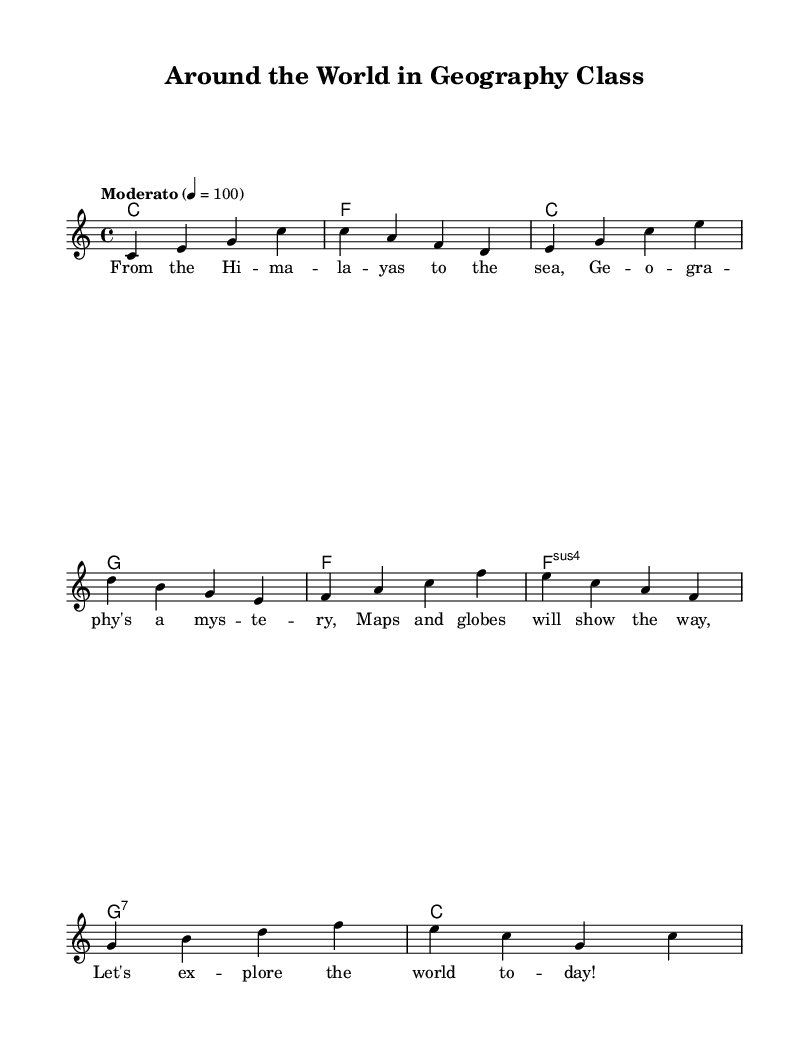What is the time signature of this music? The time signature is indicated at the beginning of the score and is shown as 4/4, meaning there are four beats in each measure, and the quarter note gets one beat.
Answer: 4/4 What key is this piece written in? The key signature is shown at the beginning and indicates C major, which has no sharps or flats.
Answer: C major What is the tempo marking of this piece? The tempo marking appears above the staff and indicates "Moderato" at a speed of 100 beats per minute, suggesting a moderate pace.
Answer: Moderato How many measures are in the music? By counting the measures in the melody line, we see there are 8 measures total in this piece, as each line is separated clearly in the notation.
Answer: 8 What is the first line of lyrics in the song? The first line of lyrics, indicated below the melody, starts with "From the Hi -- ma -- la -- yas to the sea," which expresses a geographical reference.
Answer: From the Hi -- ma -- la -- yas to the sea, Which chord is played on the first measure? The first measure in the harmonies section indicates a C major chord, which is the root chord of the piece.
Answer: C What is the last chord of the piece? The last measure in the harmonies section shows a C major chord, which concludes the piece, reinforcing the tonic throughout the song structure.
Answer: C 